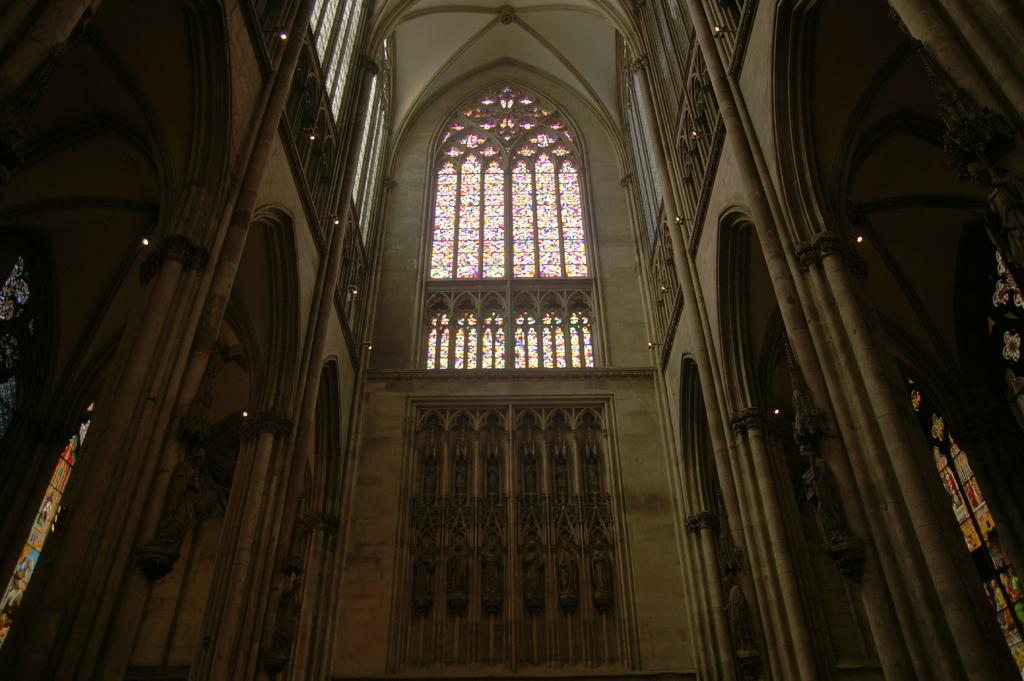What type of location is depicted in the image? The image is an inside picture of a building. What can be seen on the wall in the image? There are sculptures on the wall in the image. What news is being offered by the arm in the image? There is no arm or news present in the image; it only features sculptures on the wall. 